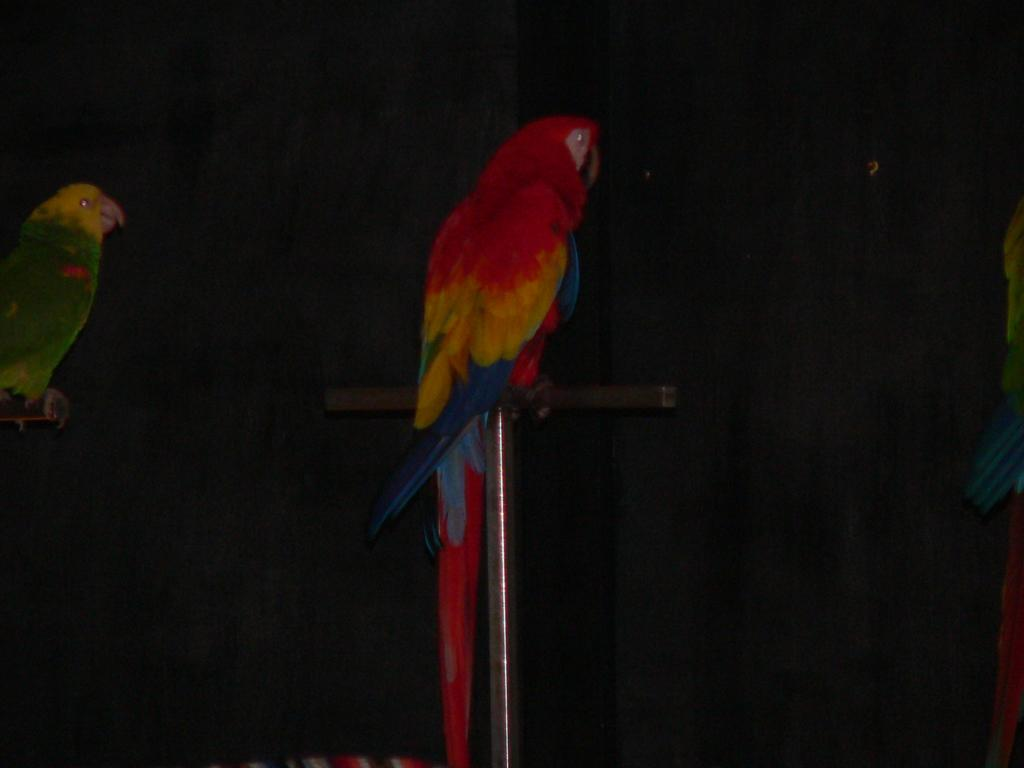What type of animals are in the image? There are parrots in the image. What are the parrots standing on? The parrots are standing on poles. Can you tell me how many members are on the team of parrots driving the moon in the image? There is no team of parrots driving the moon in the image; it only features parrots standing on poles. 